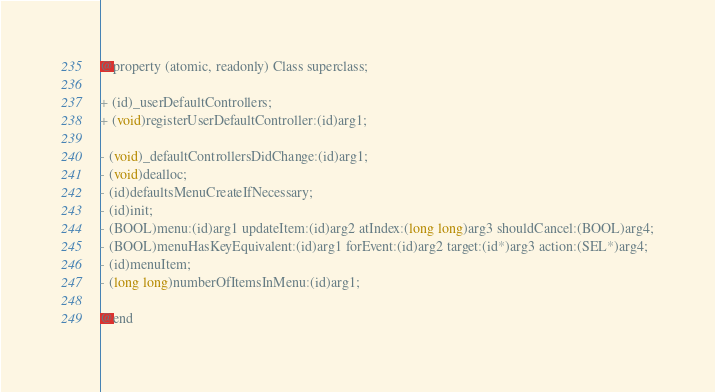Convert code to text. <code><loc_0><loc_0><loc_500><loc_500><_C_>@property (atomic, readonly) Class superclass;

+ (id)_userDefaultControllers;
+ (void)registerUserDefaultController:(id)arg1;

- (void)_defaultControllersDidChange:(id)arg1;
- (void)dealloc;
- (id)defaultsMenuCreateIfNecessary;
- (id)init;
- (BOOL)menu:(id)arg1 updateItem:(id)arg2 atIndex:(long long)arg3 shouldCancel:(BOOL)arg4;
- (BOOL)menuHasKeyEquivalent:(id)arg1 forEvent:(id)arg2 target:(id*)arg3 action:(SEL*)arg4;
- (id)menuItem;
- (long long)numberOfItemsInMenu:(id)arg1;

@end
</code> 